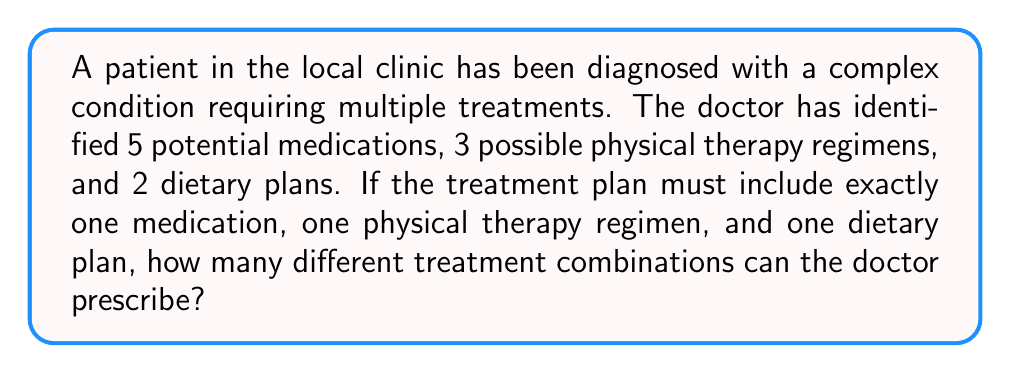Could you help me with this problem? Let's approach this step-by-step using the multiplication principle of combinatorics:

1) We need to choose one option from each category:
   - 1 medication out of 5
   - 1 physical therapy regimen out of 3
   - 1 dietary plan out of 2

2) For each category, we're making an independent choice. This means we can multiply the number of choices for each category:

   $$ \text{Total combinations} = (\text{Medication options}) \times (\text{Physical therapy options}) \times (\text{Dietary plan options}) $$

3) Substituting the numbers:

   $$ \text{Total combinations} = 5 \times 3 \times 2 $$

4) Calculating:

   $$ \text{Total combinations} = 30 $$

Therefore, the doctor can prescribe 30 different treatment combinations.
Answer: 30 